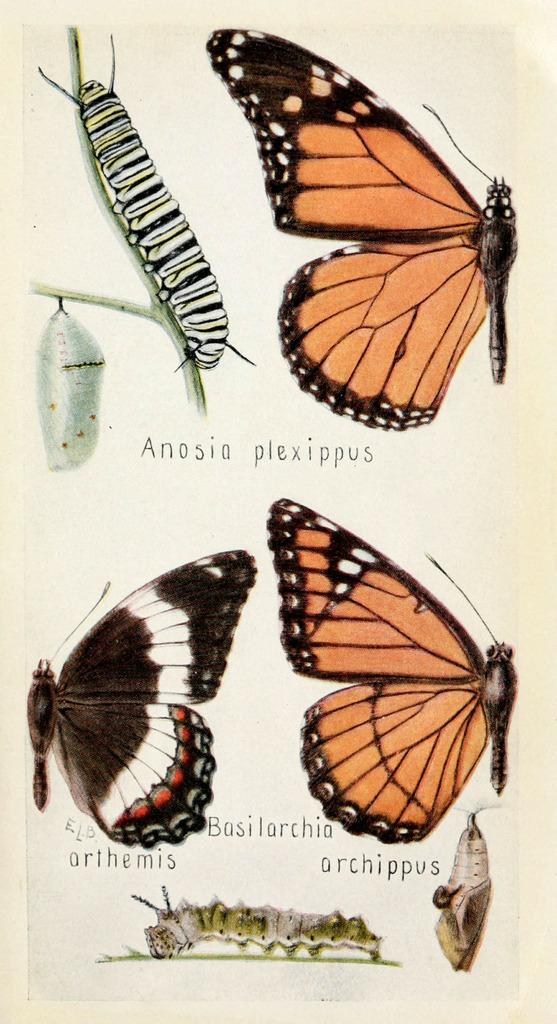What is the medium of the image? The image is on a paper. What type of creatures are depicted in the image? There are butterflies and worms in the image. Is there any text present in the image? Yes, there is text in the image. What type of bulb is used to light up the morning in the image? There is no mention of a bulb or morning in the image; it features butterflies, worms, and text on a paper. 